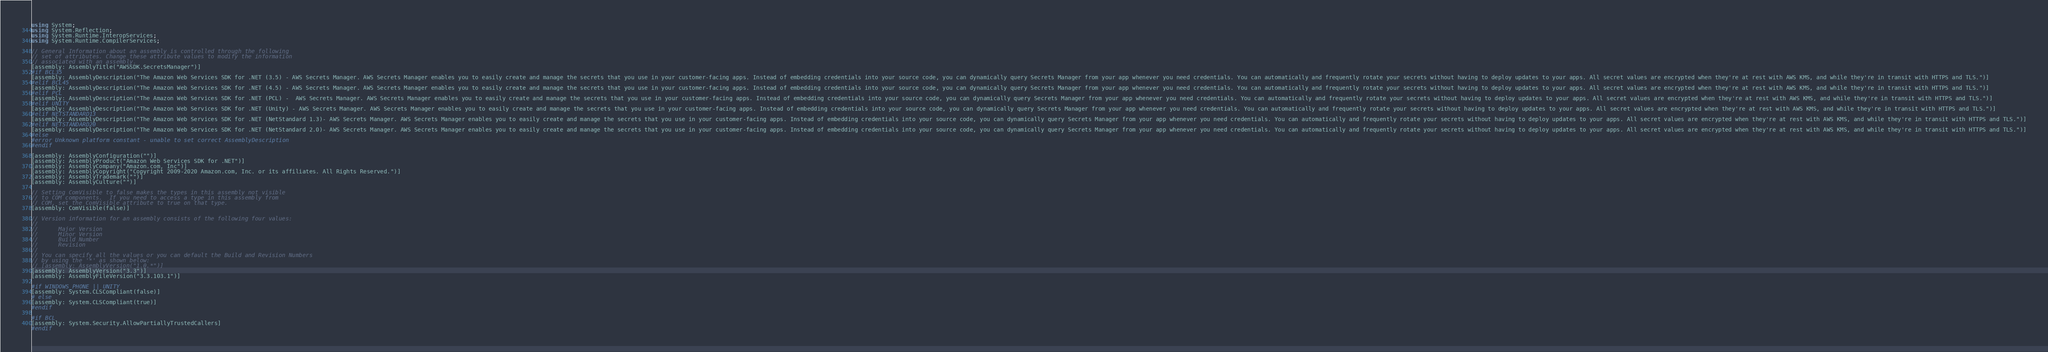Convert code to text. <code><loc_0><loc_0><loc_500><loc_500><_C#_>using System;
using System.Reflection;
using System.Runtime.InteropServices;
using System.Runtime.CompilerServices;

// General Information about an assembly is controlled through the following 
// set of attributes. Change these attribute values to modify the information
// associated with an assembly.
[assembly: AssemblyTitle("AWSSDK.SecretsManager")]
#if BCL35
[assembly: AssemblyDescription("The Amazon Web Services SDK for .NET (3.5) - AWS Secrets Manager. AWS Secrets Manager enables you to easily create and manage the secrets that you use in your customer-facing apps. Instead of embedding credentials into your source code, you can dynamically query Secrets Manager from your app whenever you need credentials. You can automatically and frequently rotate your secrets without having to deploy updates to your apps. All secret values are encrypted when they're at rest with AWS KMS, and while they're in transit with HTTPS and TLS.")]
#elif BCL45
[assembly: AssemblyDescription("The Amazon Web Services SDK for .NET (4.5) - AWS Secrets Manager. AWS Secrets Manager enables you to easily create and manage the secrets that you use in your customer-facing apps. Instead of embedding credentials into your source code, you can dynamically query Secrets Manager from your app whenever you need credentials. You can automatically and frequently rotate your secrets without having to deploy updates to your apps. All secret values are encrypted when they're at rest with AWS KMS, and while they're in transit with HTTPS and TLS.")]
#elif PCL
[assembly: AssemblyDescription("The Amazon Web Services SDK for .NET (PCL) -  AWS Secrets Manager. AWS Secrets Manager enables you to easily create and manage the secrets that you use in your customer-facing apps. Instead of embedding credentials into your source code, you can dynamically query Secrets Manager from your app whenever you need credentials. You can automatically and frequently rotate your secrets without having to deploy updates to your apps. All secret values are encrypted when they're at rest with AWS KMS, and while they're in transit with HTTPS and TLS.")]
#elif UNITY
[assembly: AssemblyDescription("The Amazon Web Services SDK for .NET (Unity) - AWS Secrets Manager. AWS Secrets Manager enables you to easily create and manage the secrets that you use in your customer-facing apps. Instead of embedding credentials into your source code, you can dynamically query Secrets Manager from your app whenever you need credentials. You can automatically and frequently rotate your secrets without having to deploy updates to your apps. All secret values are encrypted when they're at rest with AWS KMS, and while they're in transit with HTTPS and TLS.")]
#elif NETSTANDARD13
[assembly: AssemblyDescription("The Amazon Web Services SDK for .NET (NetStandard 1.3)- AWS Secrets Manager. AWS Secrets Manager enables you to easily create and manage the secrets that you use in your customer-facing apps. Instead of embedding credentials into your source code, you can dynamically query Secrets Manager from your app whenever you need credentials. You can automatically and frequently rotate your secrets without having to deploy updates to your apps. All secret values are encrypted when they're at rest with AWS KMS, and while they're in transit with HTTPS and TLS.")]
#elif NETSTANDARD20
[assembly: AssemblyDescription("The Amazon Web Services SDK for .NET (NetStandard 2.0)- AWS Secrets Manager. AWS Secrets Manager enables you to easily create and manage the secrets that you use in your customer-facing apps. Instead of embedding credentials into your source code, you can dynamically query Secrets Manager from your app whenever you need credentials. You can automatically and frequently rotate your secrets without having to deploy updates to your apps. All secret values are encrypted when they're at rest with AWS KMS, and while they're in transit with HTTPS and TLS.")]
#else
#error Unknown platform constant - unable to set correct AssemblyDescription
#endif

[assembly: AssemblyConfiguration("")]
[assembly: AssemblyProduct("Amazon Web Services SDK for .NET")]
[assembly: AssemblyCompany("Amazon.com, Inc")]
[assembly: AssemblyCopyright("Copyright 2009-2020 Amazon.com, Inc. or its affiliates. All Rights Reserved.")]
[assembly: AssemblyTrademark("")]
[assembly: AssemblyCulture("")]

// Setting ComVisible to false makes the types in this assembly not visible 
// to COM components.  If you need to access a type in this assembly from 
// COM, set the ComVisible attribute to true on that type.
[assembly: ComVisible(false)]

// Version information for an assembly consists of the following four values:
//
//      Major Version
//      Minor Version 
//      Build Number
//      Revision
//
// You can specify all the values or you can default the Build and Revision Numbers 
// by using the '*' as shown below:
// [assembly: AssemblyVersion("1.0.*")]
[assembly: AssemblyVersion("3.3")]
[assembly: AssemblyFileVersion("3.3.103.1")]

#if WINDOWS_PHONE || UNITY
[assembly: System.CLSCompliant(false)]
# else
[assembly: System.CLSCompliant(true)]
#endif

#if BCL
[assembly: System.Security.AllowPartiallyTrustedCallers]
#endif</code> 